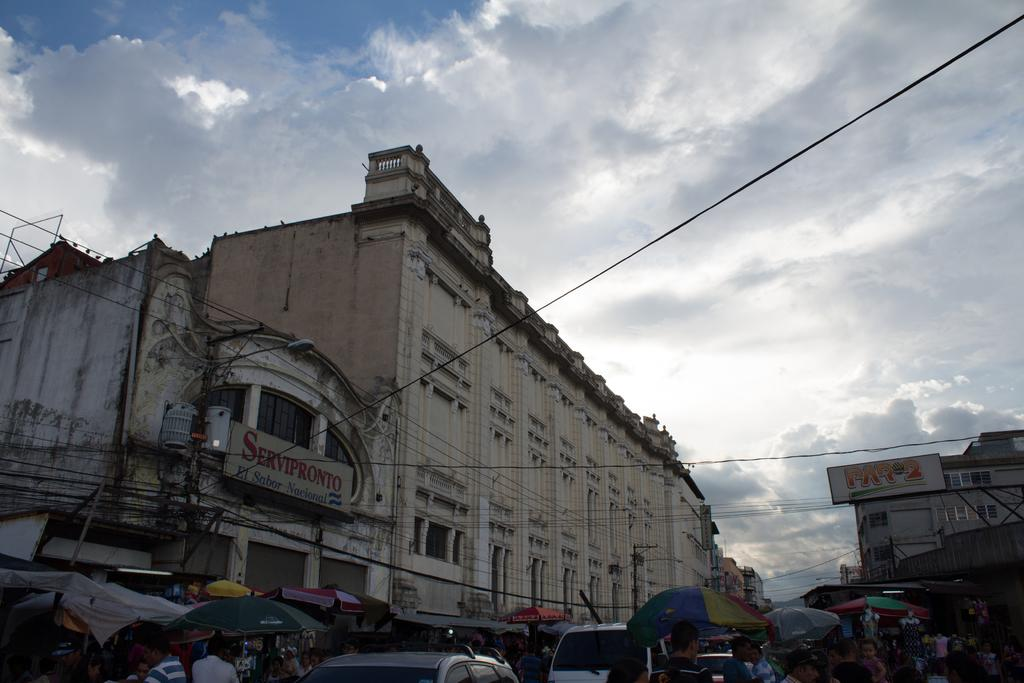What type of structures can be seen in the image? There are buildings in the image. What part of the natural environment is visible in the image? The sky is visible in the image. What objects are being used for protection from the elements in the image? There are umbrellas in the image. What type of living organisms can be seen in the image? There are people in the image. What mode of transportation can be seen in the image? Vehicles are present in the image. What type of infrastructure is visible in the image? There are poles with wires attached in the image. What type of turkey is being served at the restaurant in the image? There is no restaurant or turkey present in the image. What material are the people's hearts made of in the image? There is no mention of people's hearts in the image, and it is not possible to determine their material. 